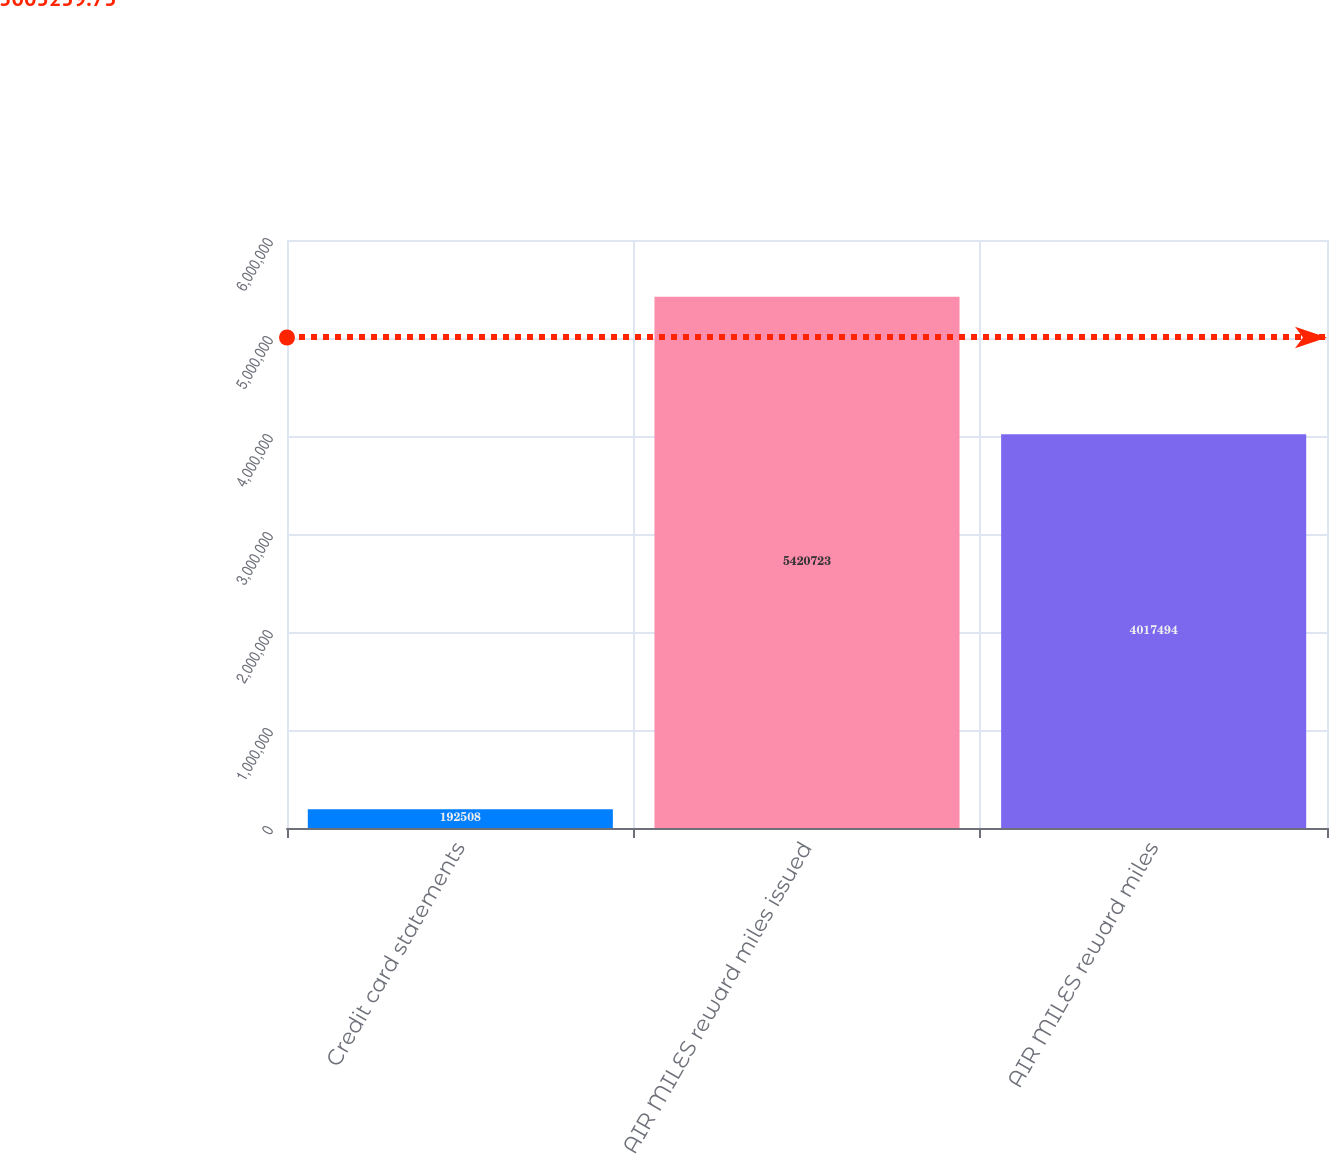Convert chart to OTSL. <chart><loc_0><loc_0><loc_500><loc_500><bar_chart><fcel>Credit card statements<fcel>AIR MILES reward miles issued<fcel>AIR MILES reward miles<nl><fcel>192508<fcel>5.42072e+06<fcel>4.01749e+06<nl></chart> 